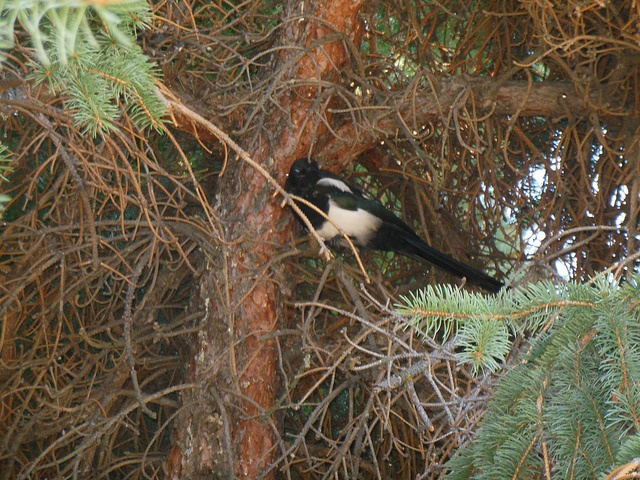Describe the objects in this image and their specific colors. I can see a bird in tan, black, gray, and darkgray tones in this image. 